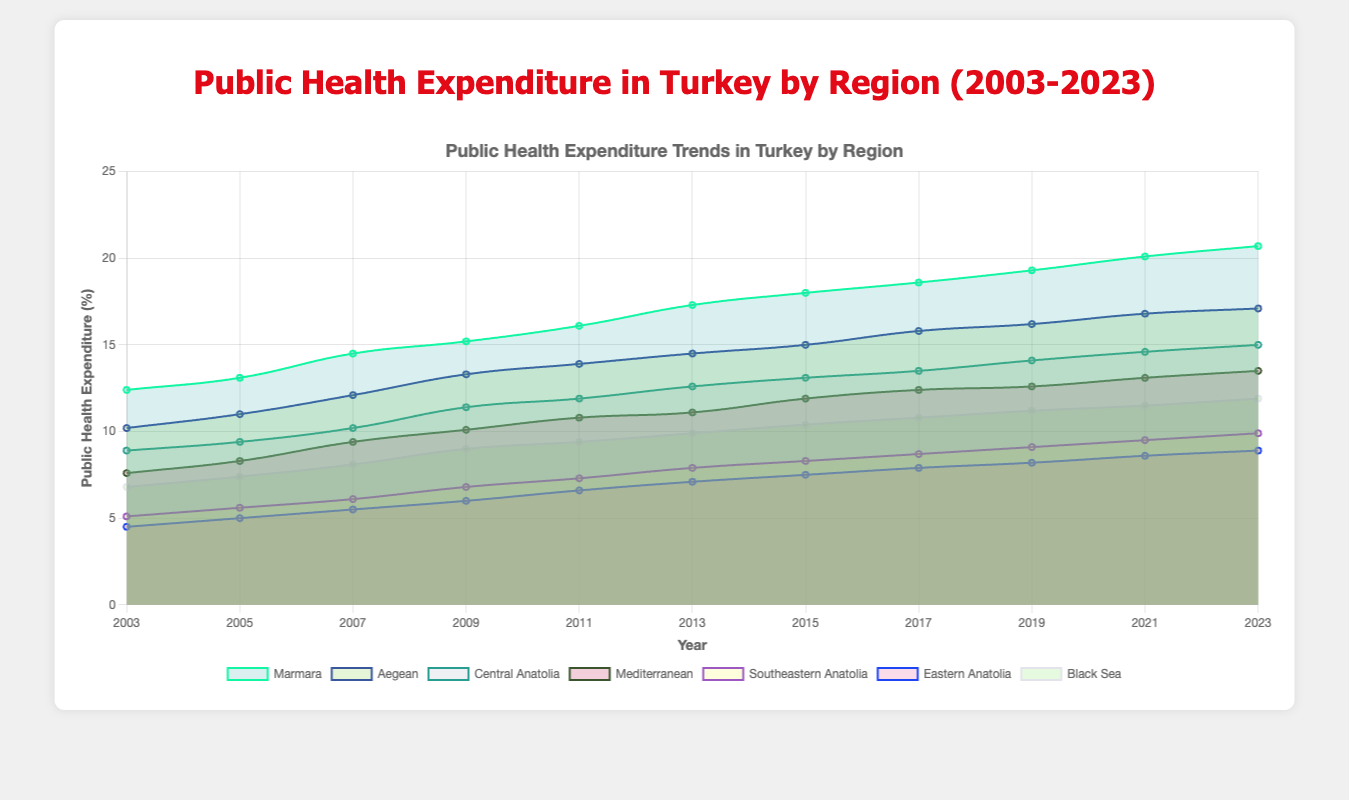Which region spent the most on public health in 2023? Observing the chart, the Marmara region consistently has the highest expenditure throughout the years, including in 2023.
Answer: Marmara How did public health expenditure in the Aegean region change from 2003 to 2023? By comparing the data points for 2003 and 2023, the values increased from 10.2% to 17.1%. This shows a steady increase in expenditure.
Answer: Increased Which two regions have the smallest difference in public health expenditure in 2023? The chart shows the values for each region for 2023. The difference between Black Sea (11.9%) and Mediterranean (13.5%) is the smallest relative to other regions.
Answer: Black Sea and Mediterranean What year did Central Anatolia first exceed 10% public health expenditure? Reviewing the data points on the chart, Central Anatolia first exceeds 10% expenditure in 2007.
Answer: 2007 By how much did public health expenditure in Southeastern Anatolia increase from 2003 to 2023? Comparing the data points for 2003 and 2023, the expenditure increased from 5.1% to 9.9%. The difference is 9.9% - 5.1% = 4.8%.
Answer: 4.8% Which region showed the most consistent growth in public health expenditure over the years? By analyzing the steady increments in expenditures on the chart, Marmara region shows the most consistent growth with no periods of decline.
Answer: Marmara Which regions had an expenditure less than 10% in 2023? From the chart, Eastern Anatolia and Southeastern Anatolia had expenditures lower than 10% in 2023.
Answer: Eastern Anatolia and Southeastern Anatolia Did any region experience a decline in public health expenditure at any point over the 20 years? Observing all regions, all areas exhibit a consistent or growing trend with no declines in any year.
Answer: No What is the difference in public health expenditure between the Marmara and Central Anatolia regions in 2023? In 2023, Marmara had an expenditure of 20.7% and Central Anatolia had 15%. The difference is 20.7% - 15% = 5.7%.
Answer: 5.7% In which year did the Marmara region's public health expenditure exceed 15%? By examining the trend in the chart, the Marmara region's expenditure exceeded 15% in 2009.
Answer: 2009 